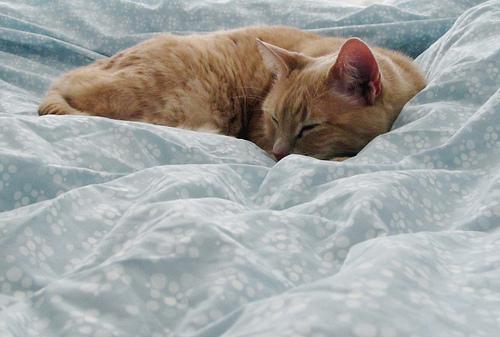How many cats are in the photo?
Give a very brief answer. 1. How many buses are there?
Give a very brief answer. 0. 